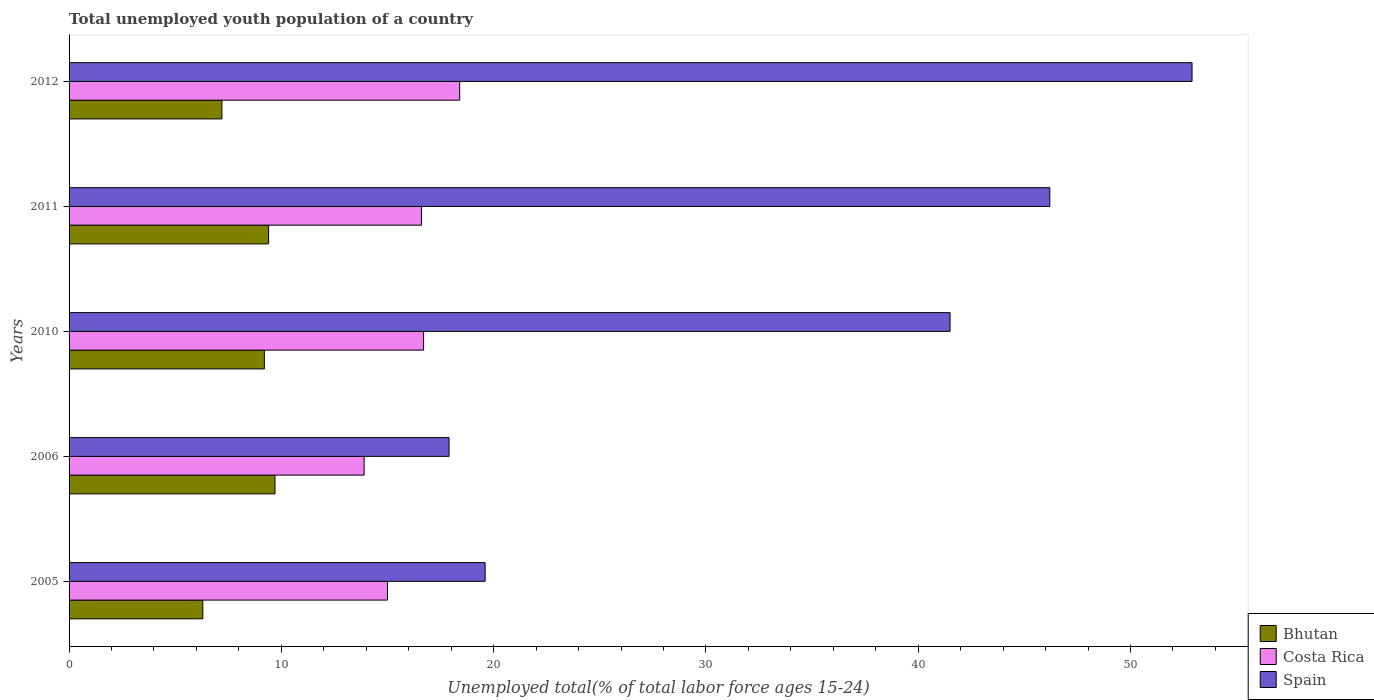How many different coloured bars are there?
Ensure brevity in your answer.  3. How many groups of bars are there?
Your answer should be very brief. 5. Are the number of bars per tick equal to the number of legend labels?
Keep it short and to the point. Yes. How many bars are there on the 1st tick from the bottom?
Make the answer very short. 3. What is the label of the 3rd group of bars from the top?
Give a very brief answer. 2010. In how many cases, is the number of bars for a given year not equal to the number of legend labels?
Ensure brevity in your answer.  0. What is the percentage of total unemployed youth population of a country in Costa Rica in 2005?
Ensure brevity in your answer.  15. Across all years, what is the maximum percentage of total unemployed youth population of a country in Bhutan?
Make the answer very short. 9.7. Across all years, what is the minimum percentage of total unemployed youth population of a country in Spain?
Make the answer very short. 17.9. In which year was the percentage of total unemployed youth population of a country in Spain maximum?
Your answer should be compact. 2012. In which year was the percentage of total unemployed youth population of a country in Costa Rica minimum?
Give a very brief answer. 2006. What is the total percentage of total unemployed youth population of a country in Bhutan in the graph?
Offer a very short reply. 41.8. What is the difference between the percentage of total unemployed youth population of a country in Costa Rica in 2005 and that in 2011?
Provide a short and direct response. -1.6. What is the difference between the percentage of total unemployed youth population of a country in Bhutan in 2006 and the percentage of total unemployed youth population of a country in Spain in 2012?
Your answer should be compact. -43.2. What is the average percentage of total unemployed youth population of a country in Costa Rica per year?
Offer a very short reply. 16.12. In the year 2011, what is the difference between the percentage of total unemployed youth population of a country in Bhutan and percentage of total unemployed youth population of a country in Costa Rica?
Keep it short and to the point. -7.2. What is the ratio of the percentage of total unemployed youth population of a country in Bhutan in 2005 to that in 2006?
Your response must be concise. 0.65. Is the percentage of total unemployed youth population of a country in Bhutan in 2005 less than that in 2010?
Give a very brief answer. Yes. Is the difference between the percentage of total unemployed youth population of a country in Bhutan in 2005 and 2011 greater than the difference between the percentage of total unemployed youth population of a country in Costa Rica in 2005 and 2011?
Offer a very short reply. No. What is the difference between the highest and the second highest percentage of total unemployed youth population of a country in Bhutan?
Give a very brief answer. 0.3. What is the difference between the highest and the lowest percentage of total unemployed youth population of a country in Spain?
Offer a terse response. 35. Is the sum of the percentage of total unemployed youth population of a country in Costa Rica in 2006 and 2011 greater than the maximum percentage of total unemployed youth population of a country in Bhutan across all years?
Give a very brief answer. Yes. What does the 1st bar from the top in 2006 represents?
Your answer should be very brief. Spain. What does the 1st bar from the bottom in 2011 represents?
Ensure brevity in your answer.  Bhutan. Are all the bars in the graph horizontal?
Offer a very short reply. Yes. How many years are there in the graph?
Offer a very short reply. 5. Does the graph contain any zero values?
Ensure brevity in your answer.  No. Where does the legend appear in the graph?
Provide a succinct answer. Bottom right. How many legend labels are there?
Ensure brevity in your answer.  3. What is the title of the graph?
Keep it short and to the point. Total unemployed youth population of a country. What is the label or title of the X-axis?
Ensure brevity in your answer.  Unemployed total(% of total labor force ages 15-24). What is the label or title of the Y-axis?
Your answer should be very brief. Years. What is the Unemployed total(% of total labor force ages 15-24) in Bhutan in 2005?
Offer a very short reply. 6.3. What is the Unemployed total(% of total labor force ages 15-24) of Spain in 2005?
Keep it short and to the point. 19.6. What is the Unemployed total(% of total labor force ages 15-24) in Bhutan in 2006?
Give a very brief answer. 9.7. What is the Unemployed total(% of total labor force ages 15-24) of Costa Rica in 2006?
Your response must be concise. 13.9. What is the Unemployed total(% of total labor force ages 15-24) of Spain in 2006?
Provide a succinct answer. 17.9. What is the Unemployed total(% of total labor force ages 15-24) in Bhutan in 2010?
Ensure brevity in your answer.  9.2. What is the Unemployed total(% of total labor force ages 15-24) in Costa Rica in 2010?
Your response must be concise. 16.7. What is the Unemployed total(% of total labor force ages 15-24) in Spain in 2010?
Make the answer very short. 41.5. What is the Unemployed total(% of total labor force ages 15-24) of Bhutan in 2011?
Your answer should be compact. 9.4. What is the Unemployed total(% of total labor force ages 15-24) in Costa Rica in 2011?
Your answer should be very brief. 16.6. What is the Unemployed total(% of total labor force ages 15-24) in Spain in 2011?
Your response must be concise. 46.2. What is the Unemployed total(% of total labor force ages 15-24) in Bhutan in 2012?
Make the answer very short. 7.2. What is the Unemployed total(% of total labor force ages 15-24) in Costa Rica in 2012?
Your answer should be compact. 18.4. What is the Unemployed total(% of total labor force ages 15-24) of Spain in 2012?
Ensure brevity in your answer.  52.9. Across all years, what is the maximum Unemployed total(% of total labor force ages 15-24) in Bhutan?
Provide a succinct answer. 9.7. Across all years, what is the maximum Unemployed total(% of total labor force ages 15-24) of Costa Rica?
Ensure brevity in your answer.  18.4. Across all years, what is the maximum Unemployed total(% of total labor force ages 15-24) of Spain?
Your answer should be very brief. 52.9. Across all years, what is the minimum Unemployed total(% of total labor force ages 15-24) of Bhutan?
Offer a terse response. 6.3. Across all years, what is the minimum Unemployed total(% of total labor force ages 15-24) of Costa Rica?
Your answer should be very brief. 13.9. Across all years, what is the minimum Unemployed total(% of total labor force ages 15-24) of Spain?
Your answer should be very brief. 17.9. What is the total Unemployed total(% of total labor force ages 15-24) of Bhutan in the graph?
Your answer should be compact. 41.8. What is the total Unemployed total(% of total labor force ages 15-24) of Costa Rica in the graph?
Give a very brief answer. 80.6. What is the total Unemployed total(% of total labor force ages 15-24) of Spain in the graph?
Provide a short and direct response. 178.1. What is the difference between the Unemployed total(% of total labor force ages 15-24) in Bhutan in 2005 and that in 2006?
Ensure brevity in your answer.  -3.4. What is the difference between the Unemployed total(% of total labor force ages 15-24) in Costa Rica in 2005 and that in 2006?
Make the answer very short. 1.1. What is the difference between the Unemployed total(% of total labor force ages 15-24) of Spain in 2005 and that in 2006?
Make the answer very short. 1.7. What is the difference between the Unemployed total(% of total labor force ages 15-24) of Bhutan in 2005 and that in 2010?
Offer a terse response. -2.9. What is the difference between the Unemployed total(% of total labor force ages 15-24) of Costa Rica in 2005 and that in 2010?
Offer a very short reply. -1.7. What is the difference between the Unemployed total(% of total labor force ages 15-24) in Spain in 2005 and that in 2010?
Keep it short and to the point. -21.9. What is the difference between the Unemployed total(% of total labor force ages 15-24) of Costa Rica in 2005 and that in 2011?
Give a very brief answer. -1.6. What is the difference between the Unemployed total(% of total labor force ages 15-24) in Spain in 2005 and that in 2011?
Offer a very short reply. -26.6. What is the difference between the Unemployed total(% of total labor force ages 15-24) in Spain in 2005 and that in 2012?
Make the answer very short. -33.3. What is the difference between the Unemployed total(% of total labor force ages 15-24) of Spain in 2006 and that in 2010?
Give a very brief answer. -23.6. What is the difference between the Unemployed total(% of total labor force ages 15-24) in Bhutan in 2006 and that in 2011?
Make the answer very short. 0.3. What is the difference between the Unemployed total(% of total labor force ages 15-24) in Costa Rica in 2006 and that in 2011?
Provide a short and direct response. -2.7. What is the difference between the Unemployed total(% of total labor force ages 15-24) in Spain in 2006 and that in 2011?
Your answer should be very brief. -28.3. What is the difference between the Unemployed total(% of total labor force ages 15-24) of Costa Rica in 2006 and that in 2012?
Ensure brevity in your answer.  -4.5. What is the difference between the Unemployed total(% of total labor force ages 15-24) in Spain in 2006 and that in 2012?
Your answer should be compact. -35. What is the difference between the Unemployed total(% of total labor force ages 15-24) of Spain in 2010 and that in 2011?
Keep it short and to the point. -4.7. What is the difference between the Unemployed total(% of total labor force ages 15-24) in Bhutan in 2010 and that in 2012?
Keep it short and to the point. 2. What is the difference between the Unemployed total(% of total labor force ages 15-24) of Costa Rica in 2010 and that in 2012?
Provide a succinct answer. -1.7. What is the difference between the Unemployed total(% of total labor force ages 15-24) of Bhutan in 2011 and that in 2012?
Offer a very short reply. 2.2. What is the difference between the Unemployed total(% of total labor force ages 15-24) of Costa Rica in 2011 and that in 2012?
Make the answer very short. -1.8. What is the difference between the Unemployed total(% of total labor force ages 15-24) of Bhutan in 2005 and the Unemployed total(% of total labor force ages 15-24) of Spain in 2006?
Provide a short and direct response. -11.6. What is the difference between the Unemployed total(% of total labor force ages 15-24) of Bhutan in 2005 and the Unemployed total(% of total labor force ages 15-24) of Costa Rica in 2010?
Provide a succinct answer. -10.4. What is the difference between the Unemployed total(% of total labor force ages 15-24) in Bhutan in 2005 and the Unemployed total(% of total labor force ages 15-24) in Spain in 2010?
Offer a terse response. -35.2. What is the difference between the Unemployed total(% of total labor force ages 15-24) in Costa Rica in 2005 and the Unemployed total(% of total labor force ages 15-24) in Spain in 2010?
Your answer should be very brief. -26.5. What is the difference between the Unemployed total(% of total labor force ages 15-24) of Bhutan in 2005 and the Unemployed total(% of total labor force ages 15-24) of Spain in 2011?
Give a very brief answer. -39.9. What is the difference between the Unemployed total(% of total labor force ages 15-24) of Costa Rica in 2005 and the Unemployed total(% of total labor force ages 15-24) of Spain in 2011?
Offer a very short reply. -31.2. What is the difference between the Unemployed total(% of total labor force ages 15-24) in Bhutan in 2005 and the Unemployed total(% of total labor force ages 15-24) in Spain in 2012?
Provide a succinct answer. -46.6. What is the difference between the Unemployed total(% of total labor force ages 15-24) in Costa Rica in 2005 and the Unemployed total(% of total labor force ages 15-24) in Spain in 2012?
Provide a short and direct response. -37.9. What is the difference between the Unemployed total(% of total labor force ages 15-24) of Bhutan in 2006 and the Unemployed total(% of total labor force ages 15-24) of Costa Rica in 2010?
Provide a succinct answer. -7. What is the difference between the Unemployed total(% of total labor force ages 15-24) in Bhutan in 2006 and the Unemployed total(% of total labor force ages 15-24) in Spain in 2010?
Offer a very short reply. -31.8. What is the difference between the Unemployed total(% of total labor force ages 15-24) of Costa Rica in 2006 and the Unemployed total(% of total labor force ages 15-24) of Spain in 2010?
Give a very brief answer. -27.6. What is the difference between the Unemployed total(% of total labor force ages 15-24) of Bhutan in 2006 and the Unemployed total(% of total labor force ages 15-24) of Costa Rica in 2011?
Your answer should be very brief. -6.9. What is the difference between the Unemployed total(% of total labor force ages 15-24) in Bhutan in 2006 and the Unemployed total(% of total labor force ages 15-24) in Spain in 2011?
Provide a succinct answer. -36.5. What is the difference between the Unemployed total(% of total labor force ages 15-24) in Costa Rica in 2006 and the Unemployed total(% of total labor force ages 15-24) in Spain in 2011?
Ensure brevity in your answer.  -32.3. What is the difference between the Unemployed total(% of total labor force ages 15-24) in Bhutan in 2006 and the Unemployed total(% of total labor force ages 15-24) in Spain in 2012?
Offer a very short reply. -43.2. What is the difference between the Unemployed total(% of total labor force ages 15-24) in Costa Rica in 2006 and the Unemployed total(% of total labor force ages 15-24) in Spain in 2012?
Give a very brief answer. -39. What is the difference between the Unemployed total(% of total labor force ages 15-24) of Bhutan in 2010 and the Unemployed total(% of total labor force ages 15-24) of Costa Rica in 2011?
Offer a very short reply. -7.4. What is the difference between the Unemployed total(% of total labor force ages 15-24) of Bhutan in 2010 and the Unemployed total(% of total labor force ages 15-24) of Spain in 2011?
Give a very brief answer. -37. What is the difference between the Unemployed total(% of total labor force ages 15-24) in Costa Rica in 2010 and the Unemployed total(% of total labor force ages 15-24) in Spain in 2011?
Your answer should be very brief. -29.5. What is the difference between the Unemployed total(% of total labor force ages 15-24) of Bhutan in 2010 and the Unemployed total(% of total labor force ages 15-24) of Costa Rica in 2012?
Make the answer very short. -9.2. What is the difference between the Unemployed total(% of total labor force ages 15-24) in Bhutan in 2010 and the Unemployed total(% of total labor force ages 15-24) in Spain in 2012?
Your answer should be very brief. -43.7. What is the difference between the Unemployed total(% of total labor force ages 15-24) in Costa Rica in 2010 and the Unemployed total(% of total labor force ages 15-24) in Spain in 2012?
Offer a terse response. -36.2. What is the difference between the Unemployed total(% of total labor force ages 15-24) of Bhutan in 2011 and the Unemployed total(% of total labor force ages 15-24) of Spain in 2012?
Offer a terse response. -43.5. What is the difference between the Unemployed total(% of total labor force ages 15-24) in Costa Rica in 2011 and the Unemployed total(% of total labor force ages 15-24) in Spain in 2012?
Your answer should be very brief. -36.3. What is the average Unemployed total(% of total labor force ages 15-24) of Bhutan per year?
Provide a succinct answer. 8.36. What is the average Unemployed total(% of total labor force ages 15-24) of Costa Rica per year?
Ensure brevity in your answer.  16.12. What is the average Unemployed total(% of total labor force ages 15-24) in Spain per year?
Offer a terse response. 35.62. In the year 2005, what is the difference between the Unemployed total(% of total labor force ages 15-24) in Costa Rica and Unemployed total(% of total labor force ages 15-24) in Spain?
Ensure brevity in your answer.  -4.6. In the year 2006, what is the difference between the Unemployed total(% of total labor force ages 15-24) in Bhutan and Unemployed total(% of total labor force ages 15-24) in Spain?
Your answer should be compact. -8.2. In the year 2010, what is the difference between the Unemployed total(% of total labor force ages 15-24) in Bhutan and Unemployed total(% of total labor force ages 15-24) in Spain?
Offer a terse response. -32.3. In the year 2010, what is the difference between the Unemployed total(% of total labor force ages 15-24) in Costa Rica and Unemployed total(% of total labor force ages 15-24) in Spain?
Offer a very short reply. -24.8. In the year 2011, what is the difference between the Unemployed total(% of total labor force ages 15-24) in Bhutan and Unemployed total(% of total labor force ages 15-24) in Spain?
Ensure brevity in your answer.  -36.8. In the year 2011, what is the difference between the Unemployed total(% of total labor force ages 15-24) of Costa Rica and Unemployed total(% of total labor force ages 15-24) of Spain?
Your response must be concise. -29.6. In the year 2012, what is the difference between the Unemployed total(% of total labor force ages 15-24) in Bhutan and Unemployed total(% of total labor force ages 15-24) in Costa Rica?
Offer a terse response. -11.2. In the year 2012, what is the difference between the Unemployed total(% of total labor force ages 15-24) in Bhutan and Unemployed total(% of total labor force ages 15-24) in Spain?
Offer a terse response. -45.7. In the year 2012, what is the difference between the Unemployed total(% of total labor force ages 15-24) in Costa Rica and Unemployed total(% of total labor force ages 15-24) in Spain?
Offer a terse response. -34.5. What is the ratio of the Unemployed total(% of total labor force ages 15-24) of Bhutan in 2005 to that in 2006?
Provide a short and direct response. 0.65. What is the ratio of the Unemployed total(% of total labor force ages 15-24) in Costa Rica in 2005 to that in 2006?
Make the answer very short. 1.08. What is the ratio of the Unemployed total(% of total labor force ages 15-24) in Spain in 2005 to that in 2006?
Make the answer very short. 1.09. What is the ratio of the Unemployed total(% of total labor force ages 15-24) of Bhutan in 2005 to that in 2010?
Offer a terse response. 0.68. What is the ratio of the Unemployed total(% of total labor force ages 15-24) of Costa Rica in 2005 to that in 2010?
Your answer should be compact. 0.9. What is the ratio of the Unemployed total(% of total labor force ages 15-24) in Spain in 2005 to that in 2010?
Offer a very short reply. 0.47. What is the ratio of the Unemployed total(% of total labor force ages 15-24) in Bhutan in 2005 to that in 2011?
Offer a terse response. 0.67. What is the ratio of the Unemployed total(% of total labor force ages 15-24) in Costa Rica in 2005 to that in 2011?
Offer a very short reply. 0.9. What is the ratio of the Unemployed total(% of total labor force ages 15-24) of Spain in 2005 to that in 2011?
Your answer should be very brief. 0.42. What is the ratio of the Unemployed total(% of total labor force ages 15-24) of Costa Rica in 2005 to that in 2012?
Keep it short and to the point. 0.82. What is the ratio of the Unemployed total(% of total labor force ages 15-24) of Spain in 2005 to that in 2012?
Keep it short and to the point. 0.37. What is the ratio of the Unemployed total(% of total labor force ages 15-24) in Bhutan in 2006 to that in 2010?
Give a very brief answer. 1.05. What is the ratio of the Unemployed total(% of total labor force ages 15-24) in Costa Rica in 2006 to that in 2010?
Provide a short and direct response. 0.83. What is the ratio of the Unemployed total(% of total labor force ages 15-24) in Spain in 2006 to that in 2010?
Offer a terse response. 0.43. What is the ratio of the Unemployed total(% of total labor force ages 15-24) of Bhutan in 2006 to that in 2011?
Ensure brevity in your answer.  1.03. What is the ratio of the Unemployed total(% of total labor force ages 15-24) in Costa Rica in 2006 to that in 2011?
Provide a succinct answer. 0.84. What is the ratio of the Unemployed total(% of total labor force ages 15-24) in Spain in 2006 to that in 2011?
Your response must be concise. 0.39. What is the ratio of the Unemployed total(% of total labor force ages 15-24) in Bhutan in 2006 to that in 2012?
Keep it short and to the point. 1.35. What is the ratio of the Unemployed total(% of total labor force ages 15-24) of Costa Rica in 2006 to that in 2012?
Your answer should be very brief. 0.76. What is the ratio of the Unemployed total(% of total labor force ages 15-24) of Spain in 2006 to that in 2012?
Give a very brief answer. 0.34. What is the ratio of the Unemployed total(% of total labor force ages 15-24) of Bhutan in 2010 to that in 2011?
Ensure brevity in your answer.  0.98. What is the ratio of the Unemployed total(% of total labor force ages 15-24) in Costa Rica in 2010 to that in 2011?
Give a very brief answer. 1.01. What is the ratio of the Unemployed total(% of total labor force ages 15-24) in Spain in 2010 to that in 2011?
Offer a terse response. 0.9. What is the ratio of the Unemployed total(% of total labor force ages 15-24) of Bhutan in 2010 to that in 2012?
Ensure brevity in your answer.  1.28. What is the ratio of the Unemployed total(% of total labor force ages 15-24) in Costa Rica in 2010 to that in 2012?
Offer a terse response. 0.91. What is the ratio of the Unemployed total(% of total labor force ages 15-24) in Spain in 2010 to that in 2012?
Offer a very short reply. 0.78. What is the ratio of the Unemployed total(% of total labor force ages 15-24) in Bhutan in 2011 to that in 2012?
Provide a succinct answer. 1.31. What is the ratio of the Unemployed total(% of total labor force ages 15-24) of Costa Rica in 2011 to that in 2012?
Ensure brevity in your answer.  0.9. What is the ratio of the Unemployed total(% of total labor force ages 15-24) in Spain in 2011 to that in 2012?
Your answer should be compact. 0.87. What is the difference between the highest and the second highest Unemployed total(% of total labor force ages 15-24) of Spain?
Your response must be concise. 6.7. What is the difference between the highest and the lowest Unemployed total(% of total labor force ages 15-24) in Bhutan?
Ensure brevity in your answer.  3.4. What is the difference between the highest and the lowest Unemployed total(% of total labor force ages 15-24) of Costa Rica?
Ensure brevity in your answer.  4.5. What is the difference between the highest and the lowest Unemployed total(% of total labor force ages 15-24) in Spain?
Keep it short and to the point. 35. 